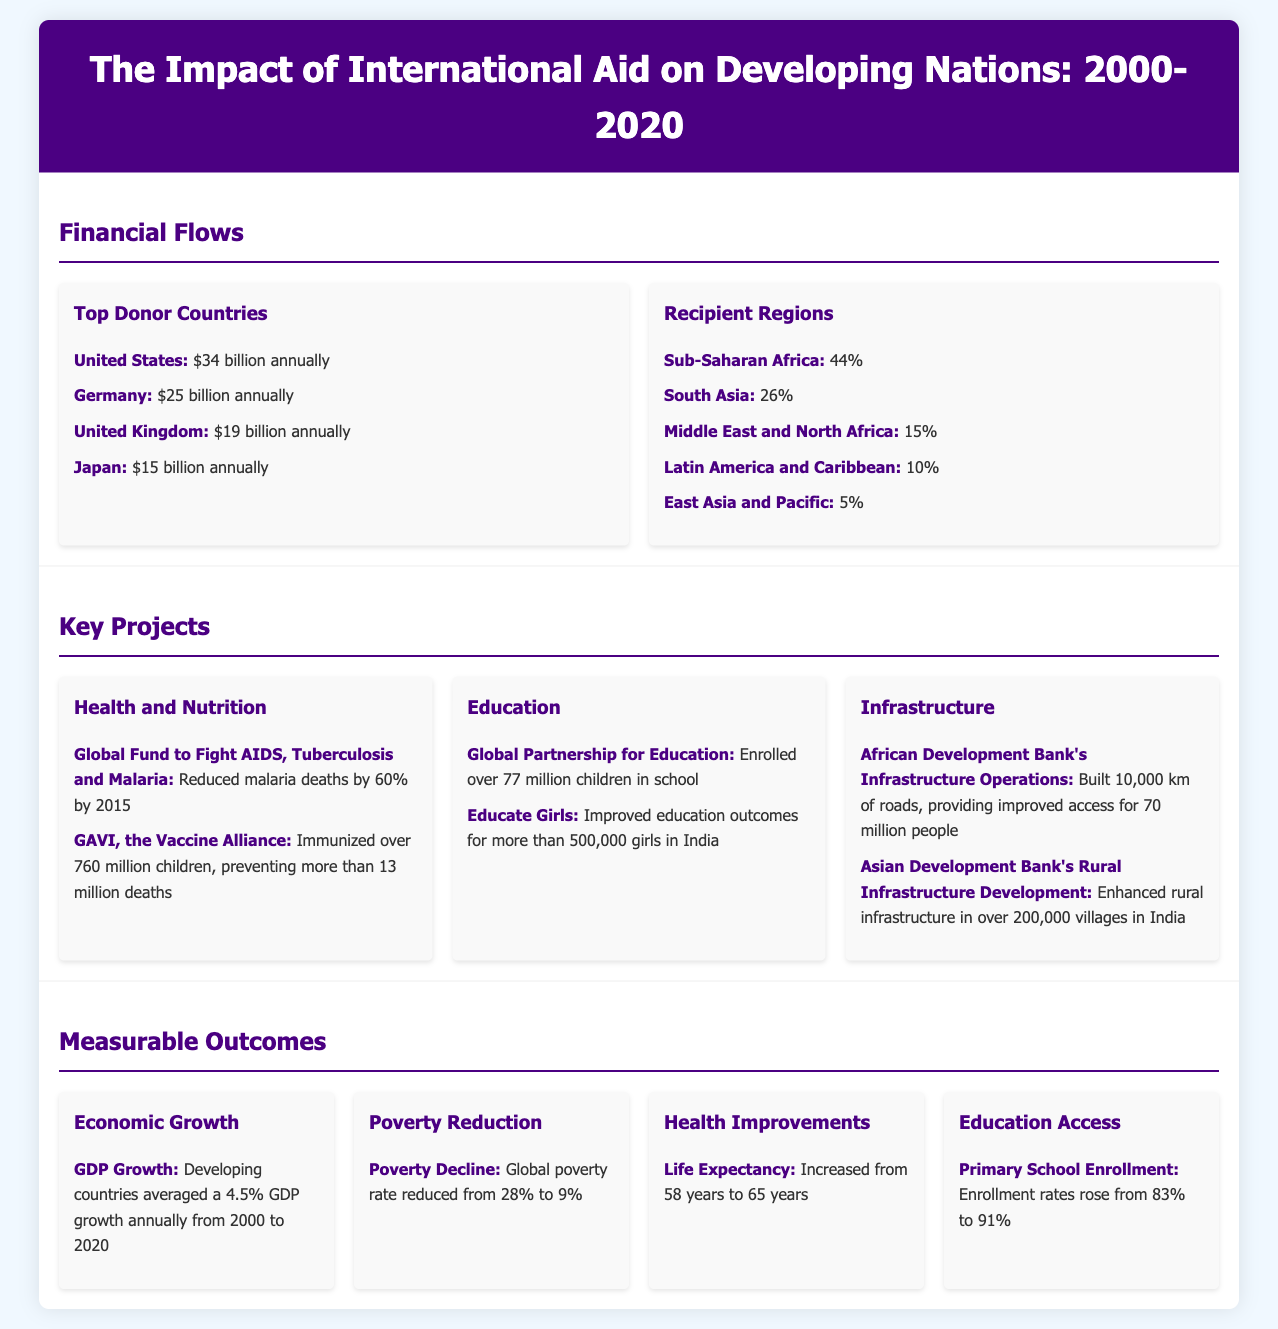What is the annual aid from the United States? The document states that the United States contributes $34 billion annually in aid.
Answer: $34 billion Which region receives the largest percentage of international aid? According to the infographic, Sub-Saharan Africa receives 44% of the international aid.
Answer: Sub-Saharan Africa How many children were immunized by GAVI? The document notes that GAVI, the Vaccine Alliance, immunized over 760 million children.
Answer: 760 million What was the GDP growth rate for developing countries from 2000 to 2020? The infographic mentions that developing countries averaged a 4.5% GDP growth annually during this period.
Answer: 4.5% By how much did the global poverty rate decline? The document states that the global poverty rate reduced from 28% to 9%.
Answer: From 28% to 9% How many kilometers of roads were built by the African Development Bank? The infographic highlights that the African Development Bank built 10,000 km of roads.
Answer: 10,000 km What was the life expectancy increase from 2000 to 2020? The document indicates that life expectancy increased from 58 years to 65 years.
Answer: From 58 years to 65 years How many children were enrolled in school by the Global Partnership for Education? The document states that over 77 million children were enrolled in school by this initiative.
Answer: 77 million Which project improved outcomes for more than 500,000 girls in India? The infographic states that the Educate Girls project improved education outcomes for this number of girls.
Answer: Educate Girls 